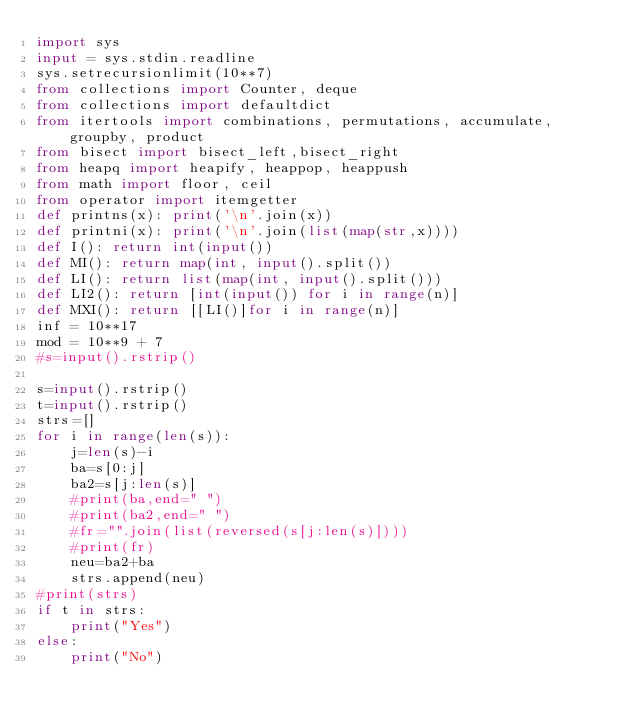<code> <loc_0><loc_0><loc_500><loc_500><_Python_>import sys
input = sys.stdin.readline
sys.setrecursionlimit(10**7)
from collections import Counter, deque
from collections import defaultdict
from itertools import combinations, permutations, accumulate, groupby, product
from bisect import bisect_left,bisect_right
from heapq import heapify, heappop, heappush
from math import floor, ceil
from operator import itemgetter
def printns(x): print('\n'.join(x))
def printni(x): print('\n'.join(list(map(str,x))))
def I(): return int(input())
def MI(): return map(int, input().split())
def LI(): return list(map(int, input().split()))
def LI2(): return [int(input()) for i in range(n)]
def MXI(): return [[LI()]for i in range(n)]
inf = 10**17
mod = 10**9 + 7
#s=input().rstrip()

s=input().rstrip()
t=input().rstrip()
strs=[]
for i in range(len(s)):
    j=len(s)-i
    ba=s[0:j]
    ba2=s[j:len(s)]
    #print(ba,end=" ")
    #print(ba2,end=" ")
    #fr="".join(list(reversed(s[j:len(s)])))
    #print(fr)
    neu=ba2+ba
    strs.append(neu)
#print(strs)
if t in strs:
    print("Yes")
else:
    print("No")
    </code> 